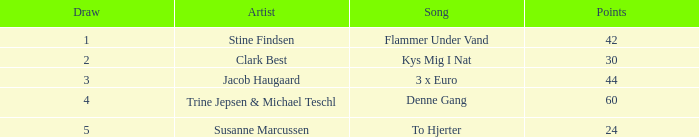What is the mean draw when the place exceeds 5? None. 